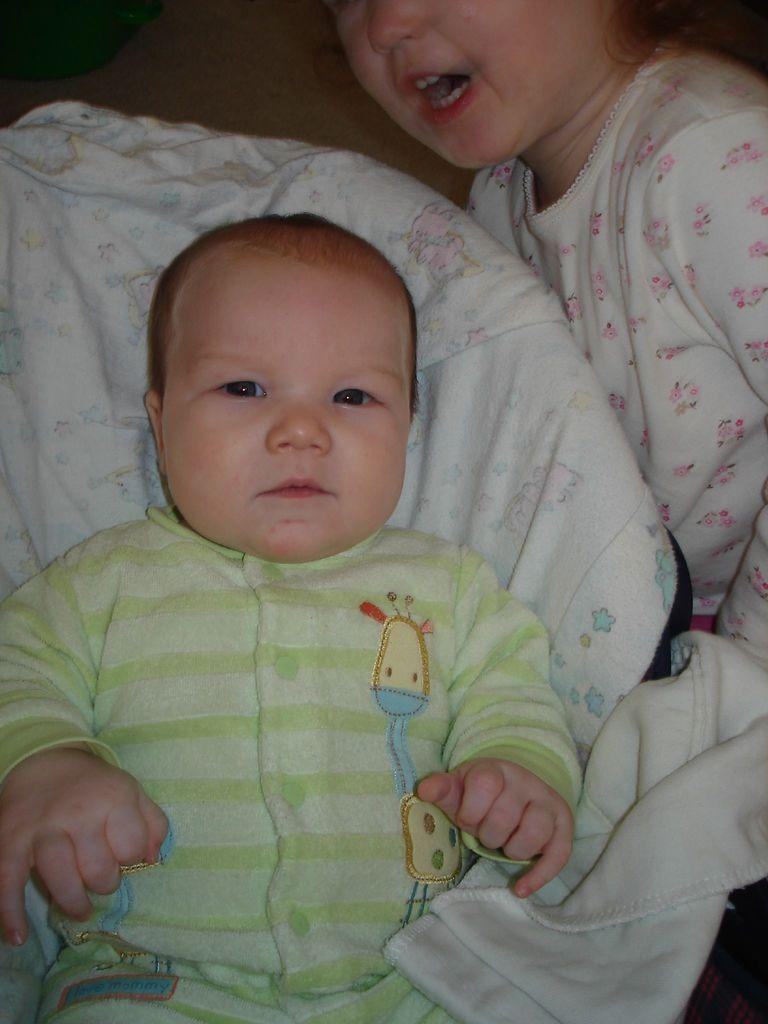What is the main subject of the image? There is a baby in the image. What is the baby lying on? The baby is lying on a cloth. Are there any other children in the image? Yes, there is a kid in the top right corner of the image. What type of mine can be seen in the background of the image? There is no mine present in the image; it features a baby lying on a cloth and a kid in the top right corner. How many goldfish are swimming in the baby's crib? There is no crib or goldfish present in the image. 